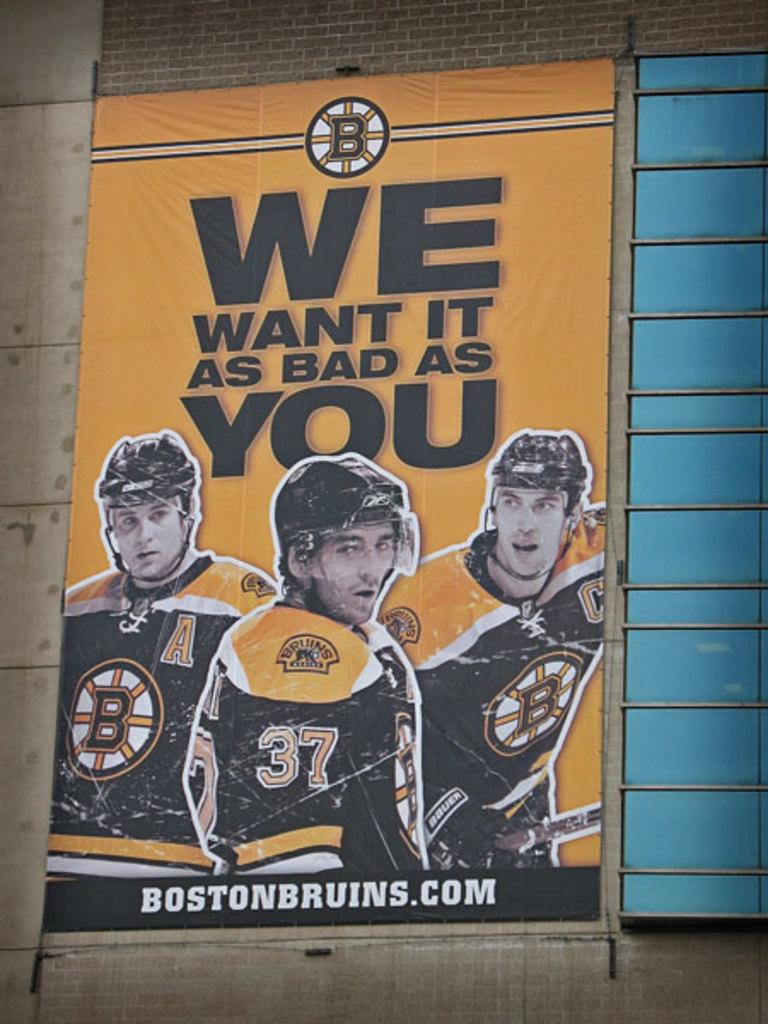<image>
Render a clear and concise summary of the photo. An ad for the Boston Bruins has three players on it. 